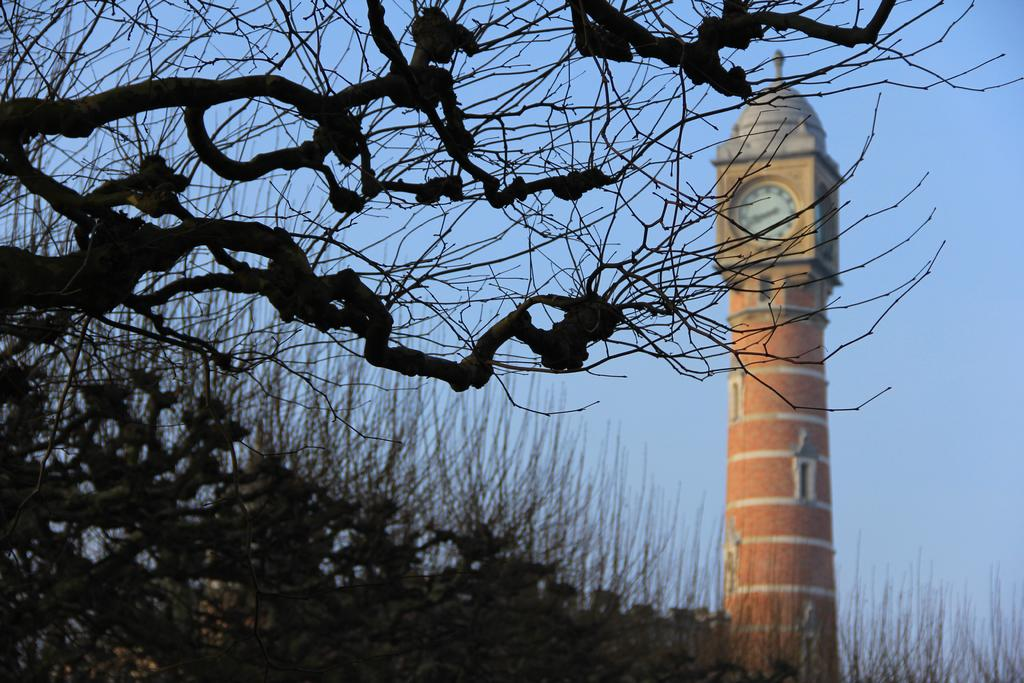What type of vegetation can be seen in the image? There are trees in the image. What structure is present in the image? There is a tower with windows in the image. What feature is on the tower? The tower has a clock on it. What can be seen in the background of the image? The sky is visible in the background of the image. What type of celery is being used as a straw in the image? There is no celery or straw present in the image. 